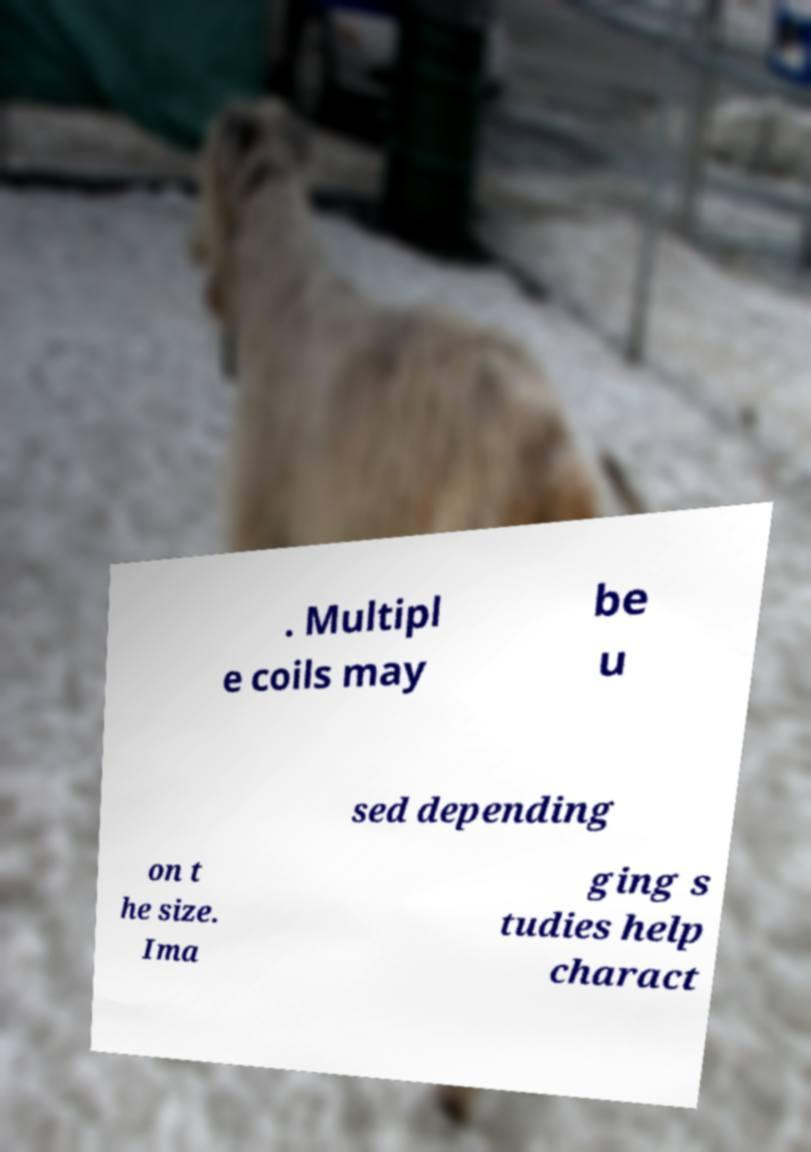What messages or text are displayed in this image? I need them in a readable, typed format. . Multipl e coils may be u sed depending on t he size. Ima ging s tudies help charact 